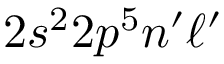<formula> <loc_0><loc_0><loc_500><loc_500>2 s ^ { 2 } 2 p ^ { 5 } n ^ { \prime } \ell ^ { \prime }</formula> 